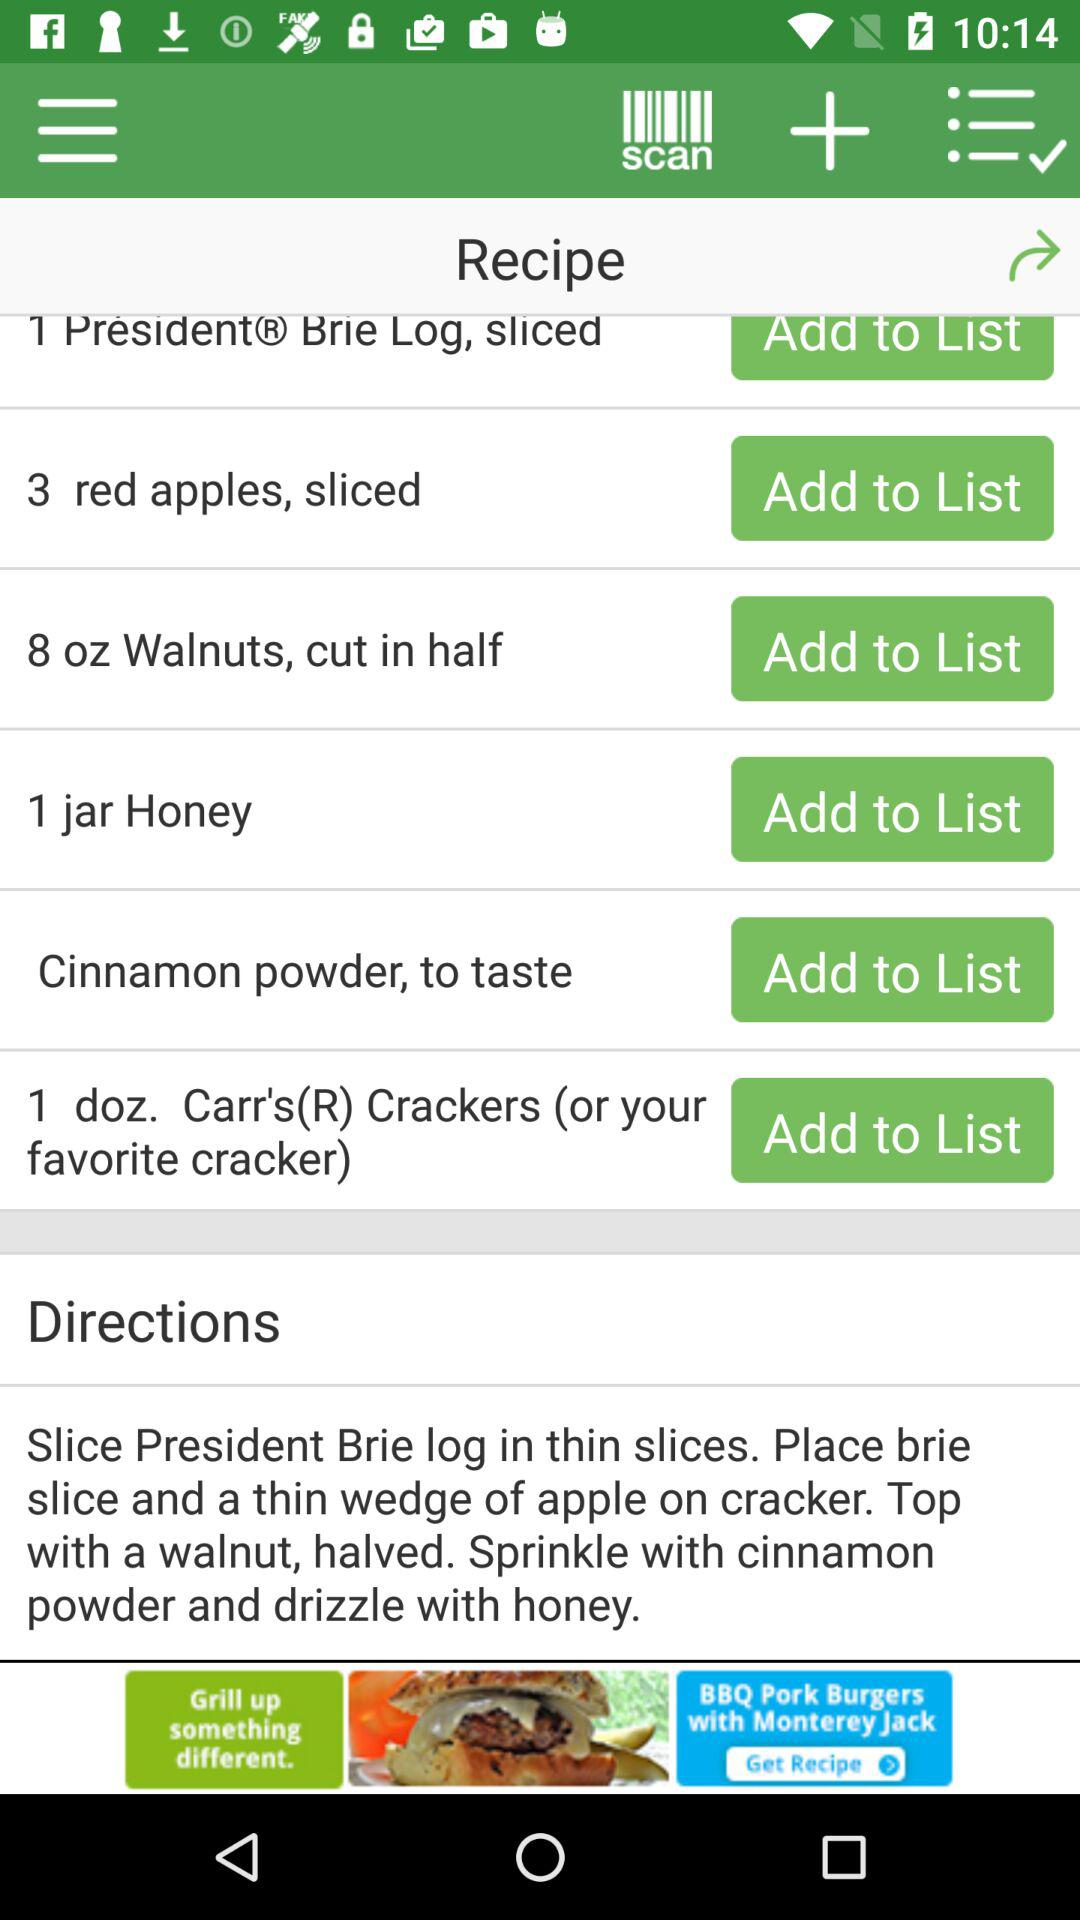What are the given directions for the recipe?
Answer the question using a single word or phrase. The given direction for the recipe is "Slice President Brie log in thin slices. Place brie slice and a thin wedge of apple on cracker. Top with a walnut, halved. Sprinkle with cinnamon powder and drizzle with honey." 